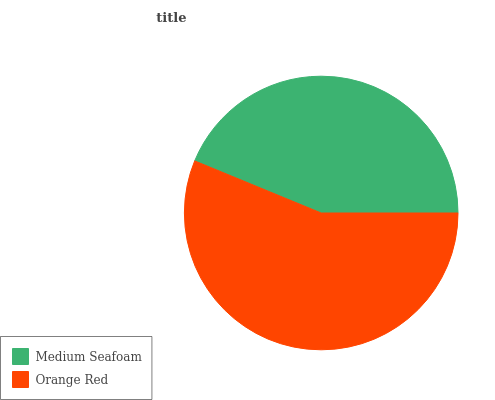Is Medium Seafoam the minimum?
Answer yes or no. Yes. Is Orange Red the maximum?
Answer yes or no. Yes. Is Orange Red the minimum?
Answer yes or no. No. Is Orange Red greater than Medium Seafoam?
Answer yes or no. Yes. Is Medium Seafoam less than Orange Red?
Answer yes or no. Yes. Is Medium Seafoam greater than Orange Red?
Answer yes or no. No. Is Orange Red less than Medium Seafoam?
Answer yes or no. No. Is Orange Red the high median?
Answer yes or no. Yes. Is Medium Seafoam the low median?
Answer yes or no. Yes. Is Medium Seafoam the high median?
Answer yes or no. No. Is Orange Red the low median?
Answer yes or no. No. 